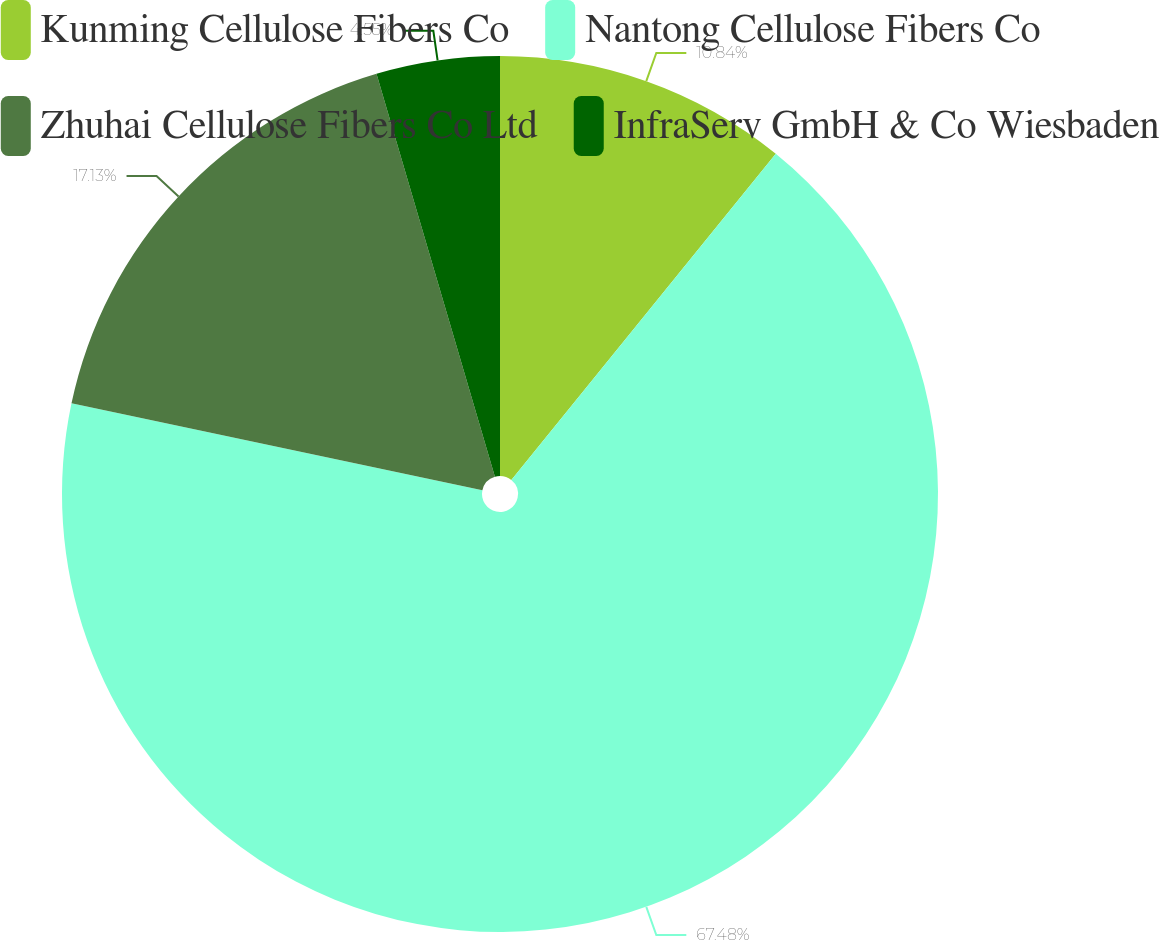Convert chart. <chart><loc_0><loc_0><loc_500><loc_500><pie_chart><fcel>Kunming Cellulose Fibers Co<fcel>Nantong Cellulose Fibers Co<fcel>Zhuhai Cellulose Fibers Co Ltd<fcel>InfraServ GmbH & Co Wiesbaden<nl><fcel>10.84%<fcel>67.48%<fcel>17.13%<fcel>4.55%<nl></chart> 